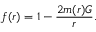Convert formula to latex. <formula><loc_0><loc_0><loc_500><loc_500>f ( r ) = 1 - \frac { 2 m ( r ) G } { r } .</formula> 